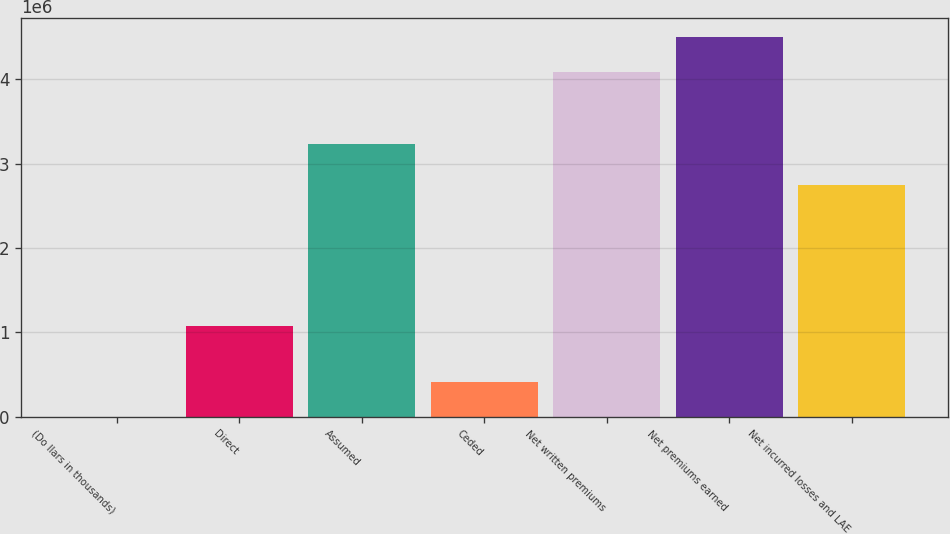Convert chart to OTSL. <chart><loc_0><loc_0><loc_500><loc_500><bar_chart><fcel>(Do llars in thousands)<fcel>Direct<fcel>Assumed<fcel>Ceded<fcel>Net written premiums<fcel>Net premiums earned<fcel>Net incurred losses and LAE<nl><fcel>2012<fcel>1.07421e+06<fcel>3.23633e+06<fcel>418274<fcel>4.08107e+06<fcel>4.49733e+06<fcel>2.74526e+06<nl></chart> 